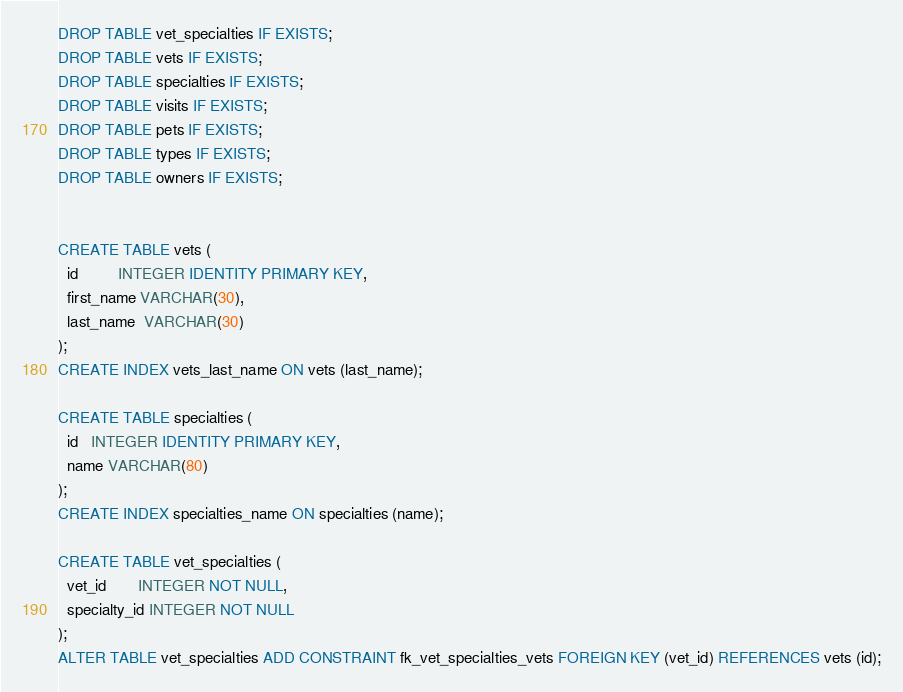Convert code to text. <code><loc_0><loc_0><loc_500><loc_500><_SQL_>DROP TABLE vet_specialties IF EXISTS;
DROP TABLE vets IF EXISTS;
DROP TABLE specialties IF EXISTS;
DROP TABLE visits IF EXISTS;
DROP TABLE pets IF EXISTS;
DROP TABLE types IF EXISTS;
DROP TABLE owners IF EXISTS;


CREATE TABLE vets (
  id         INTEGER IDENTITY PRIMARY KEY,
  first_name VARCHAR(30),
  last_name  VARCHAR(30)
);
CREATE INDEX vets_last_name ON vets (last_name);

CREATE TABLE specialties (
  id   INTEGER IDENTITY PRIMARY KEY,
  name VARCHAR(80)
);
CREATE INDEX specialties_name ON specialties (name);

CREATE TABLE vet_specialties (
  vet_id       INTEGER NOT NULL,
  specialty_id INTEGER NOT NULL
);
ALTER TABLE vet_specialties ADD CONSTRAINT fk_vet_specialties_vets FOREIGN KEY (vet_id) REFERENCES vets (id);</code> 